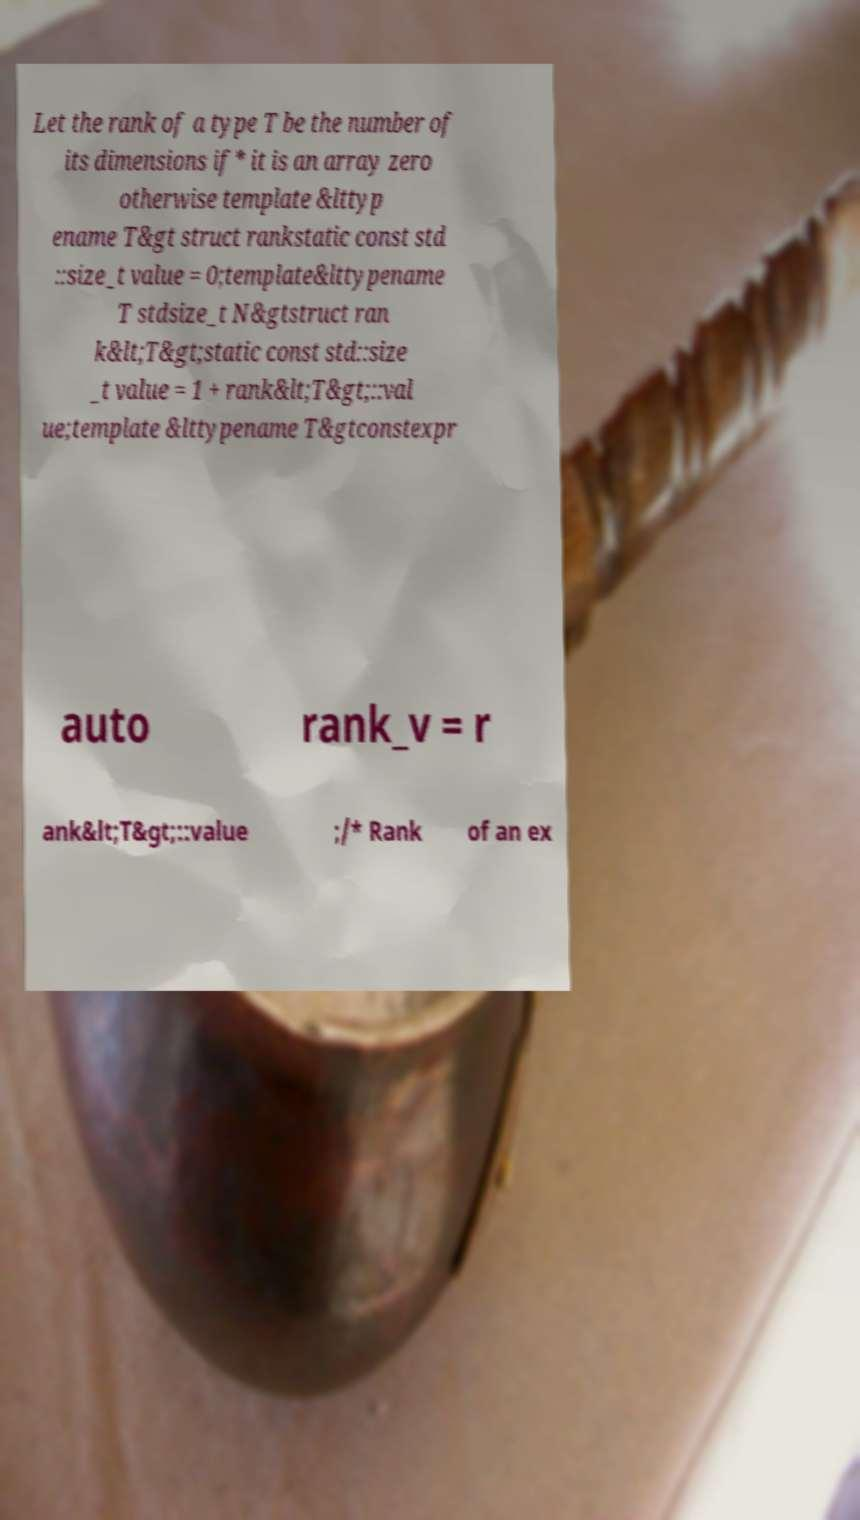Could you extract and type out the text from this image? Let the rank of a type T be the number of its dimensions if* it is an array zero otherwise template &lttyp ename T&gt struct rankstatic const std ::size_t value = 0;template&lttypename T stdsize_t N&gtstruct ran k&lt;T&gt;static const std::size _t value = 1 + rank&lt;T&gt;::val ue;template &lttypename T&gtconstexpr auto rank_v = r ank&lt;T&gt;::value ;/* Rank of an ex 